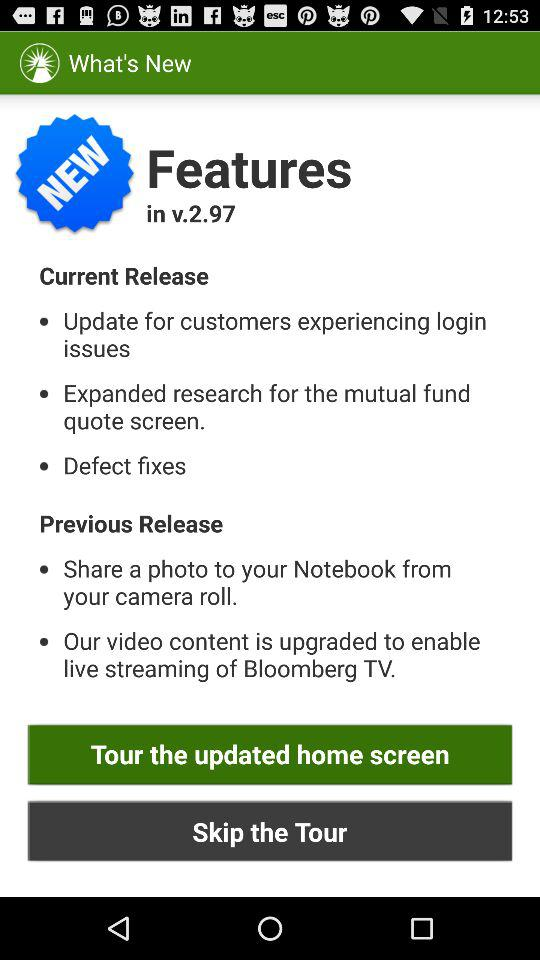What are the new features in v.2.97? The new features are "Update for customers experiencing login issues", "Expanded research for the mutual fund quote screen." and "Defect fixes". 